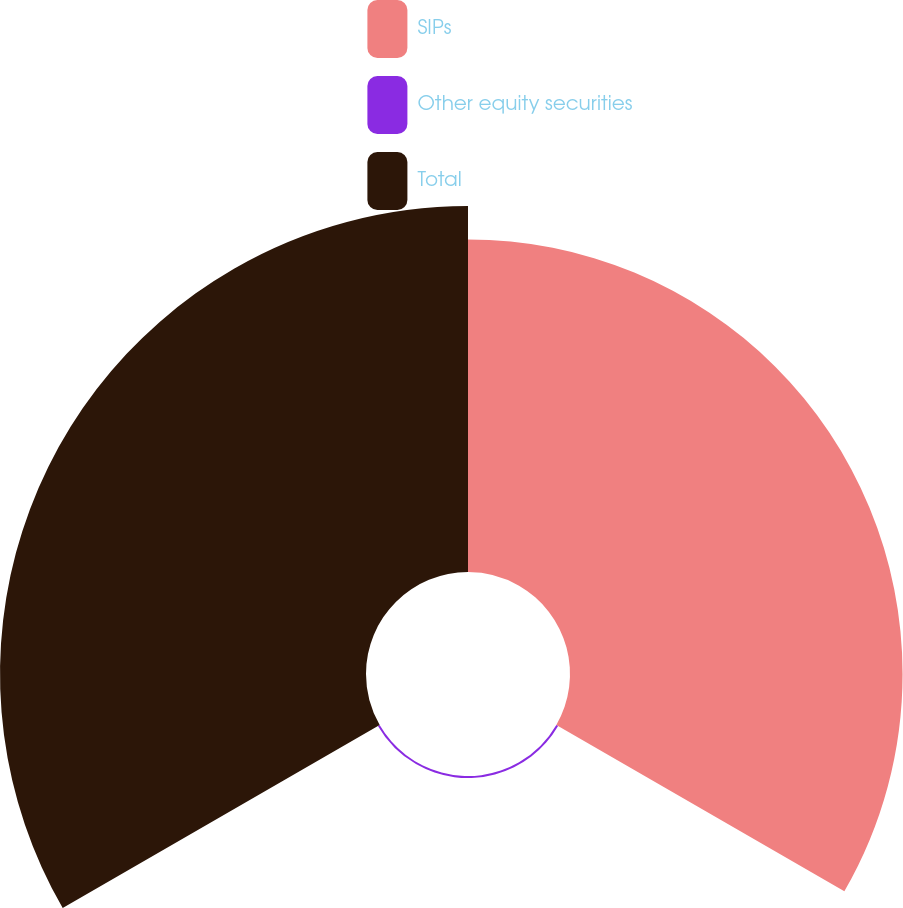<chart> <loc_0><loc_0><loc_500><loc_500><pie_chart><fcel>SIPs<fcel>Other equity securities<fcel>Total<nl><fcel>47.47%<fcel>0.29%<fcel>52.24%<nl></chart> 